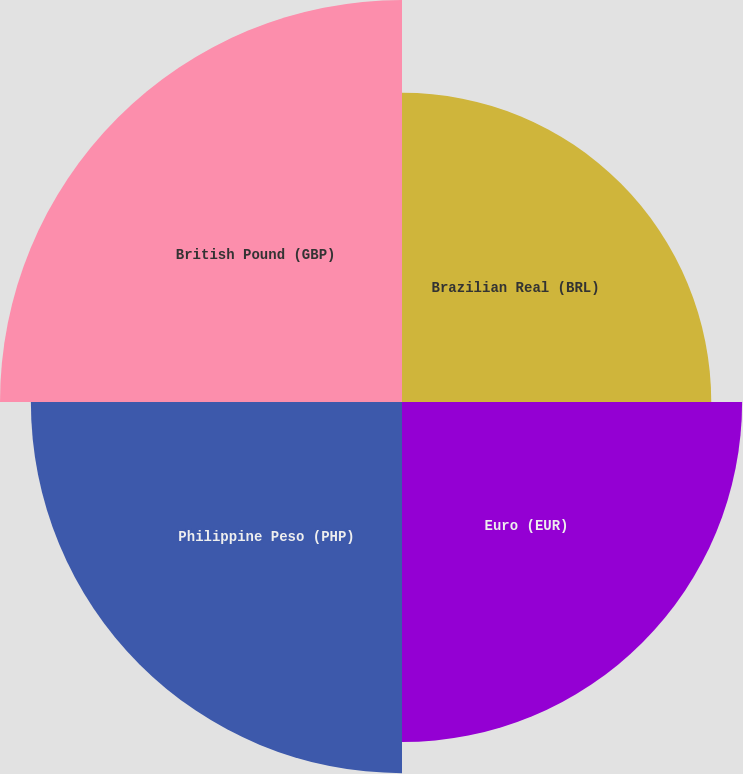Convert chart. <chart><loc_0><loc_0><loc_500><loc_500><pie_chart><fcel>Brazilian Real (BRL)<fcel>Euro (EUR)<fcel>Philippine Peso (PHP)<fcel>British Pound (GBP)<nl><fcel>21.74%<fcel>23.91%<fcel>26.09%<fcel>28.26%<nl></chart> 